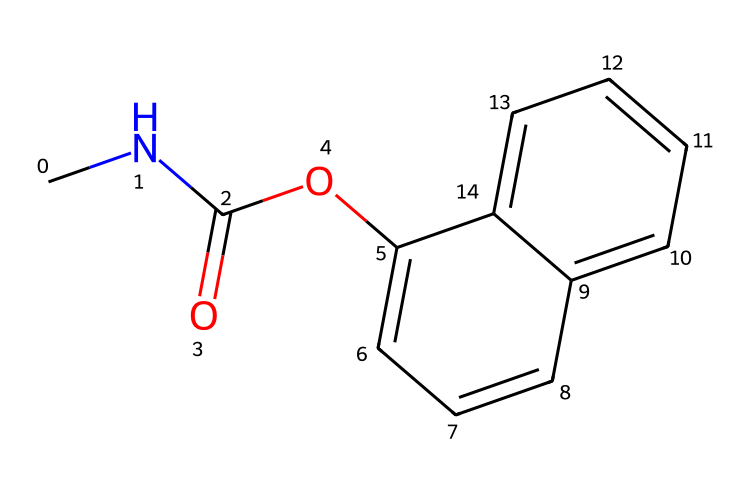What is the molecular formula of carbaryl? To determine the molecular formula, we count the number of each type of atom present in the SMILES representation. The breakdown of the SMILES reveals: 12 carbon (C) atoms, 15 hydrogen (H) atoms, 1 nitrogen (N) atom, and 1 oxygen (O) atom. This gives us the molecular formula C12H15N1O2.
Answer: C12H15NO2 How many rings are present in the structure of carbaryl? By analyzing the SMILES, we identify numbered occurrences that indicate the presence of rings. In this case, the numbers '1' and '2' indicate two connected aromatic rings. Therefore, there are two rings present.
Answer: 2 What functional groups can be identified in carbaryl? To identify the functional groups, we observe the structure indicated in the SMILES. There is an amine group (due to the nitrogen attached to carbon), an ester group (evident from the -C(=O)O- component), and an aromatic system. Hence, multiple functional groups are present: amine and ester.
Answer: amine and ester How many double bonds are present in carbaryl? We can determine the number of double bonds by examining the structure represented in the SMILES. In carbaryl, there are two notable double bonds: one in the carbonyl (C=O) and one between carbons in the aromatic rings. Therefore, there are two double bonds in total.
Answer: 2 What type of pesticide is carbaryl classified as? Carbaryl belongs to the class of insecticides, specifically a carbamate pesticide, which is known for its action on the nervous system of insects. It works by inhibiting the enzyme acetylcholinesterase. This classification is specific to its functionality.
Answer: carbamate insecticide 